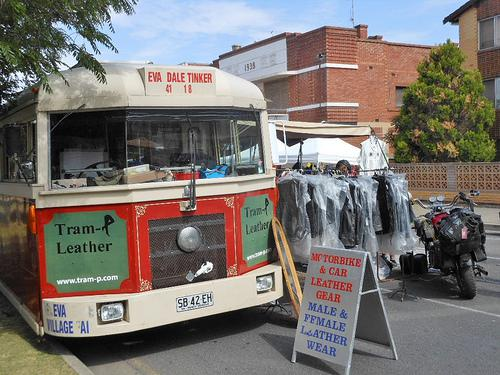Question: who is selling the leather clothing?
Choices:
A. The motorcycle shop.
B. The mobile store owner.
C. An adult store.
D. An online outlet.
Answer with the letter. Answer: B Question: what is being sold?
Choices:
A. Jewelry.
B. Hats.
C. Socks.
D. Protective clothing.
Answer with the letter. Answer: D Question: when is the picture taken?
Choices:
A. In the morning.
B. At sunset.
C. In daylight.
D. At midnight.
Answer with the letter. Answer: C Question: where is the bus parked?
Choices:
A. In the garage.
B. In the parking garage.
C. In the driveway.
D. Side of the street.
Answer with the letter. Answer: D 